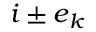Convert formula to latex. <formula><loc_0><loc_0><loc_500><loc_500>i \pm e _ { k }</formula> 